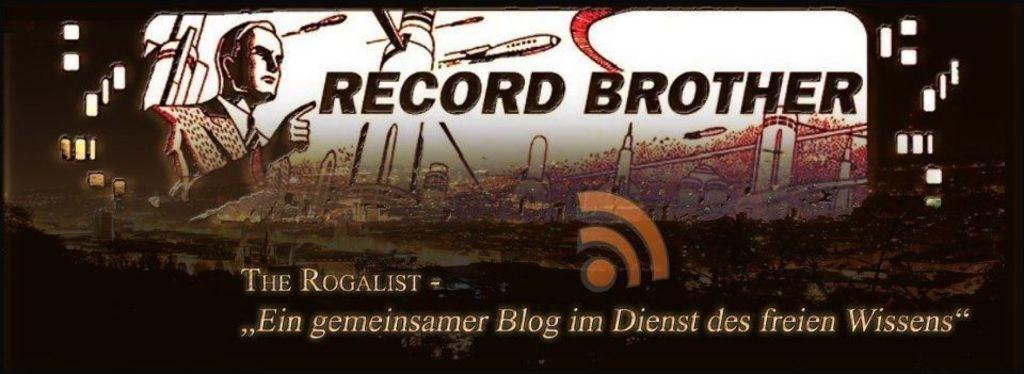<image>
Summarize the visual content of the image. Looks to be a propaganda poster that says Record Brother. 